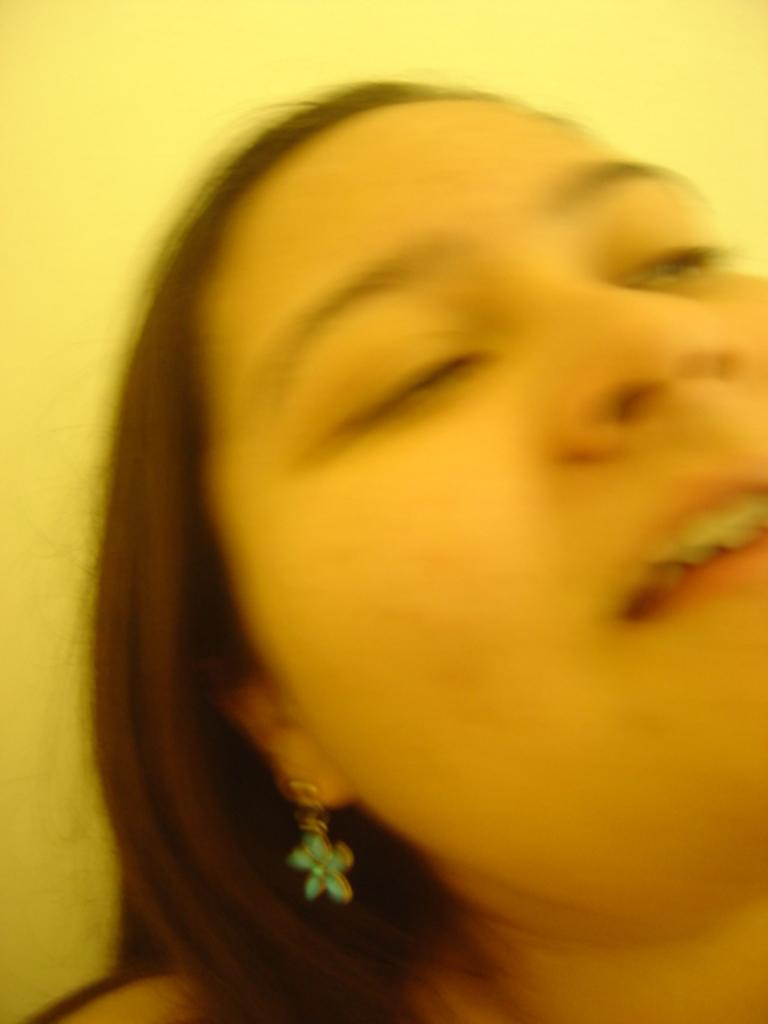What is the main subject of the image? There is a woman in the image. Can you describe the woman's appearance? The woman has black hair. What type of cheese is being used to create the thunderstorm in the image? There is no cheese or thunderstorm present in the image; it features a woman with black hair. 